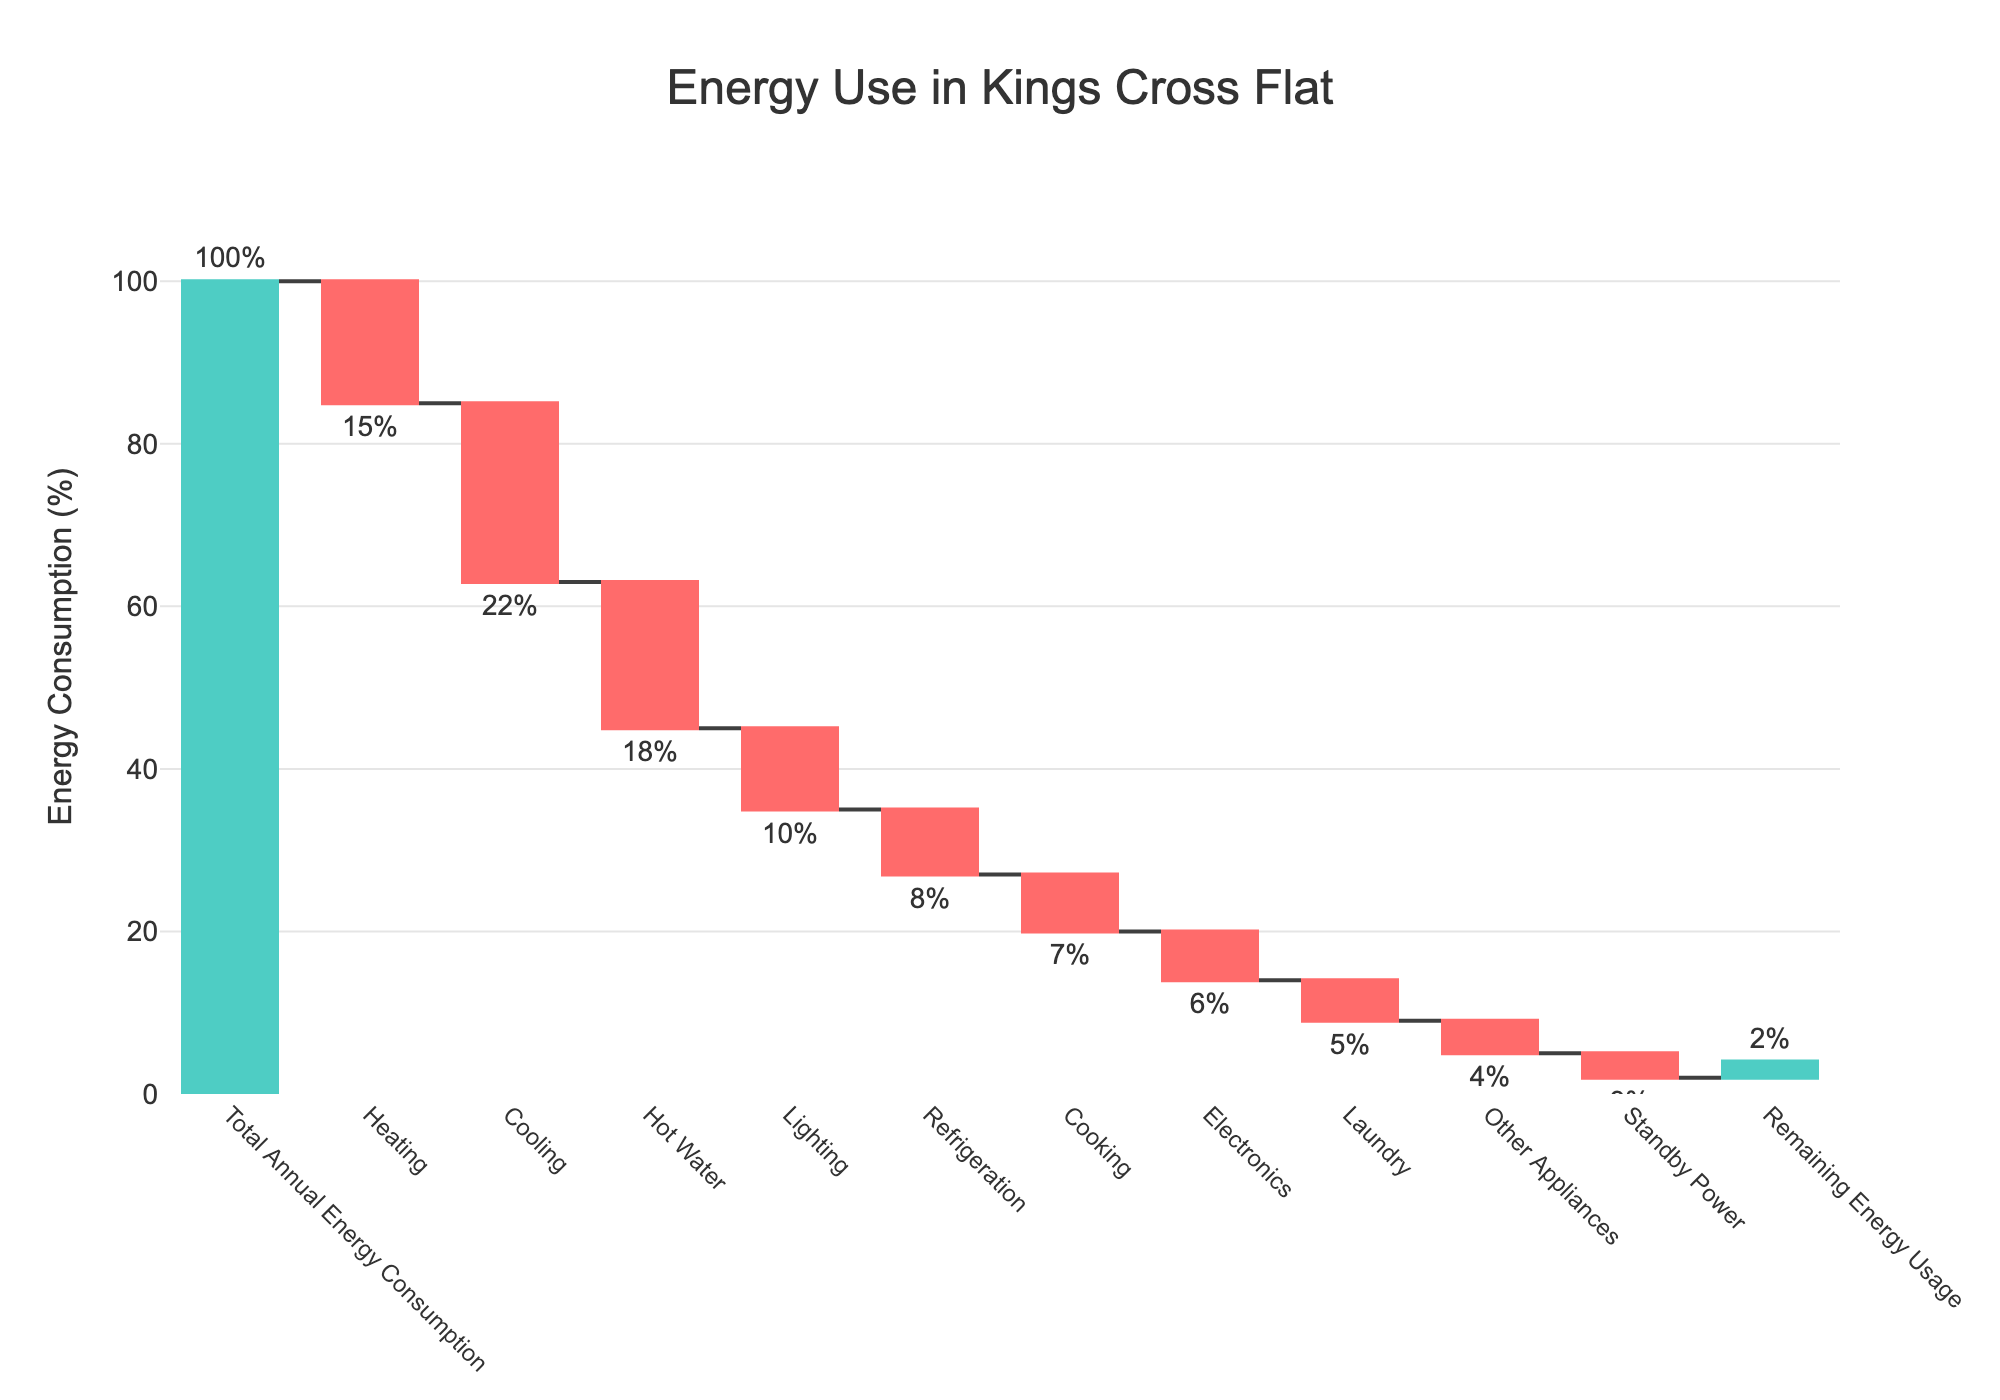What is the title of the figure? The title is typically written at the top of the chart. It clearly labels the subject of the chart as "Energy Use in Kings Cross Flat."
Answer: Energy Use in Kings Cross Flat What is the percentage of energy used for heating? Look at the bar labeled "Heating" on the chart. The text above the bar shows the percentage.
Answer: 15% Which category has the highest energy consumption reduction? Compare the lengths of all the bars that represent reductions (negative values). The longest bar indicates the highest reduction.
Answer: Cooling What is the difference in energy consumption between Cooking and Electronics? Identify the values for Cooking and Electronics from the chart and subtract one from the other. Cooking uses 7%, Electronics use 6%, so the difference is 1%.
Answer: 1% What is the total energy consumption reduction excluding the categories 'Heating' and 'Cooling'? Sum the values for all categories except for Heating and Cooling: (-18) + (-10) + (-8) + (-7) + (-6) + (-5) + (-4) + (-3) = -61%.
Answer: 61% Which category is responsible for the smallest reduction in energy consumption? Find the bar with the smallest decrease in consumption, indicated by the smallest negative value.
Answer: Standby Power What percentage of energy remains after accounting for all reductions? This is indicated by the last bar labeled "Remaining Energy Usage," showing the leftover percentage.
Answer: 2% How much more energy is used for Refrigeration compared to Laundry? Identify the values for Refrigeration and Laundry and subtract one from the other: Refrigeration uses 8%, Laundry uses 5%, so the difference is 3%.
Answer: 3% Can you calculate the sum of energy consumption for categories Cooking, Electronics, and Laundry? Add the values for Cooking, Electronics, and Laundry from the chart: 7% + 6% + 5% = 18%.
Answer: 18% How does Lighting's energy consumption compare to Standby Power? Compare the values of Lighting and Standby Power. Lighting uses 10%, and Standby Power uses 3%, so Lighting uses 7% more.
Answer: 7% more 